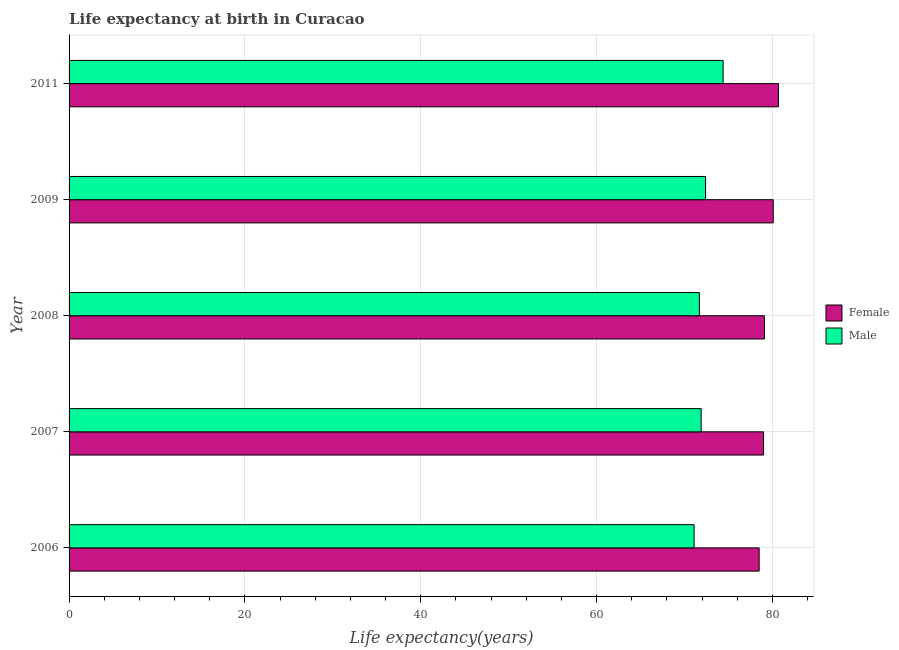How many different coloured bars are there?
Your answer should be very brief. 2. Are the number of bars per tick equal to the number of legend labels?
Your response must be concise. Yes. What is the label of the 4th group of bars from the top?
Your response must be concise. 2007. In how many cases, is the number of bars for a given year not equal to the number of legend labels?
Keep it short and to the point. 0. What is the life expectancy(female) in 2011?
Your response must be concise. 80.7. Across all years, what is the maximum life expectancy(male)?
Keep it short and to the point. 74.4. Across all years, what is the minimum life expectancy(female)?
Give a very brief answer. 78.5. In which year was the life expectancy(male) maximum?
Make the answer very short. 2011. What is the total life expectancy(male) in the graph?
Your answer should be compact. 361.5. What is the difference between the life expectancy(female) in 2008 and the life expectancy(male) in 2011?
Your answer should be compact. 4.7. What is the average life expectancy(female) per year?
Your answer should be very brief. 79.48. In the year 2009, what is the difference between the life expectancy(female) and life expectancy(male)?
Your answer should be very brief. 7.7. In how many years, is the life expectancy(male) greater than 76 years?
Give a very brief answer. 0. What is the ratio of the life expectancy(male) in 2008 to that in 2009?
Keep it short and to the point. 0.99. Is the life expectancy(female) in 2006 less than that in 2007?
Your answer should be compact. Yes. Is the sum of the life expectancy(female) in 2006 and 2009 greater than the maximum life expectancy(male) across all years?
Provide a succinct answer. Yes. Are all the bars in the graph horizontal?
Offer a terse response. Yes. What is the difference between two consecutive major ticks on the X-axis?
Keep it short and to the point. 20. Are the values on the major ticks of X-axis written in scientific E-notation?
Keep it short and to the point. No. Does the graph contain any zero values?
Your response must be concise. No. Where does the legend appear in the graph?
Your response must be concise. Center right. What is the title of the graph?
Ensure brevity in your answer.  Life expectancy at birth in Curacao. Does "Official aid received" appear as one of the legend labels in the graph?
Provide a short and direct response. No. What is the label or title of the X-axis?
Your answer should be compact. Life expectancy(years). What is the label or title of the Y-axis?
Keep it short and to the point. Year. What is the Life expectancy(years) in Female in 2006?
Offer a very short reply. 78.5. What is the Life expectancy(years) in Male in 2006?
Offer a very short reply. 71.1. What is the Life expectancy(years) in Female in 2007?
Keep it short and to the point. 79. What is the Life expectancy(years) in Male in 2007?
Offer a very short reply. 71.9. What is the Life expectancy(years) in Female in 2008?
Offer a terse response. 79.1. What is the Life expectancy(years) in Male in 2008?
Offer a terse response. 71.7. What is the Life expectancy(years) in Female in 2009?
Offer a very short reply. 80.1. What is the Life expectancy(years) of Male in 2009?
Your response must be concise. 72.4. What is the Life expectancy(years) of Female in 2011?
Provide a succinct answer. 80.7. What is the Life expectancy(years) of Male in 2011?
Give a very brief answer. 74.4. Across all years, what is the maximum Life expectancy(years) in Female?
Your answer should be very brief. 80.7. Across all years, what is the maximum Life expectancy(years) of Male?
Your response must be concise. 74.4. Across all years, what is the minimum Life expectancy(years) in Female?
Provide a short and direct response. 78.5. Across all years, what is the minimum Life expectancy(years) in Male?
Offer a very short reply. 71.1. What is the total Life expectancy(years) in Female in the graph?
Offer a very short reply. 397.4. What is the total Life expectancy(years) in Male in the graph?
Provide a short and direct response. 361.5. What is the difference between the Life expectancy(years) of Female in 2006 and that in 2007?
Provide a succinct answer. -0.5. What is the difference between the Life expectancy(years) in Male in 2006 and that in 2007?
Provide a short and direct response. -0.8. What is the difference between the Life expectancy(years) of Female in 2006 and that in 2008?
Keep it short and to the point. -0.6. What is the difference between the Life expectancy(years) in Male in 2006 and that in 2011?
Provide a succinct answer. -3.3. What is the difference between the Life expectancy(years) in Female in 2007 and that in 2008?
Make the answer very short. -0.1. What is the difference between the Life expectancy(years) in Male in 2007 and that in 2008?
Give a very brief answer. 0.2. What is the difference between the Life expectancy(years) of Female in 2008 and that in 2009?
Provide a short and direct response. -1. What is the difference between the Life expectancy(years) of Female in 2008 and that in 2011?
Provide a short and direct response. -1.6. What is the difference between the Life expectancy(years) of Male in 2008 and that in 2011?
Offer a terse response. -2.7. What is the difference between the Life expectancy(years) in Male in 2009 and that in 2011?
Provide a succinct answer. -2. What is the difference between the Life expectancy(years) of Female in 2006 and the Life expectancy(years) of Male in 2009?
Give a very brief answer. 6.1. What is the difference between the Life expectancy(years) in Female in 2006 and the Life expectancy(years) in Male in 2011?
Ensure brevity in your answer.  4.1. What is the difference between the Life expectancy(years) of Female in 2007 and the Life expectancy(years) of Male in 2008?
Offer a terse response. 7.3. What is the difference between the Life expectancy(years) of Female in 2007 and the Life expectancy(years) of Male in 2009?
Ensure brevity in your answer.  6.6. What is the difference between the Life expectancy(years) in Female in 2007 and the Life expectancy(years) in Male in 2011?
Make the answer very short. 4.6. What is the difference between the Life expectancy(years) of Female in 2008 and the Life expectancy(years) of Male in 2009?
Keep it short and to the point. 6.7. What is the average Life expectancy(years) of Female per year?
Offer a terse response. 79.48. What is the average Life expectancy(years) in Male per year?
Provide a succinct answer. 72.3. In the year 2007, what is the difference between the Life expectancy(years) of Female and Life expectancy(years) of Male?
Make the answer very short. 7.1. In the year 2008, what is the difference between the Life expectancy(years) of Female and Life expectancy(years) of Male?
Offer a very short reply. 7.4. In the year 2009, what is the difference between the Life expectancy(years) of Female and Life expectancy(years) of Male?
Offer a very short reply. 7.7. In the year 2011, what is the difference between the Life expectancy(years) of Female and Life expectancy(years) of Male?
Make the answer very short. 6.3. What is the ratio of the Life expectancy(years) in Female in 2006 to that in 2007?
Offer a very short reply. 0.99. What is the ratio of the Life expectancy(years) of Male in 2006 to that in 2007?
Give a very brief answer. 0.99. What is the ratio of the Life expectancy(years) in Female in 2006 to that in 2008?
Your answer should be very brief. 0.99. What is the ratio of the Life expectancy(years) of Female in 2006 to that in 2009?
Your response must be concise. 0.98. What is the ratio of the Life expectancy(years) in Female in 2006 to that in 2011?
Make the answer very short. 0.97. What is the ratio of the Life expectancy(years) of Male in 2006 to that in 2011?
Provide a succinct answer. 0.96. What is the ratio of the Life expectancy(years) of Female in 2007 to that in 2008?
Give a very brief answer. 1. What is the ratio of the Life expectancy(years) in Male in 2007 to that in 2008?
Provide a succinct answer. 1. What is the ratio of the Life expectancy(years) in Female in 2007 to that in 2009?
Your answer should be very brief. 0.99. What is the ratio of the Life expectancy(years) of Female in 2007 to that in 2011?
Make the answer very short. 0.98. What is the ratio of the Life expectancy(years) of Male in 2007 to that in 2011?
Ensure brevity in your answer.  0.97. What is the ratio of the Life expectancy(years) of Female in 2008 to that in 2009?
Make the answer very short. 0.99. What is the ratio of the Life expectancy(years) of Male in 2008 to that in 2009?
Your response must be concise. 0.99. What is the ratio of the Life expectancy(years) of Female in 2008 to that in 2011?
Your response must be concise. 0.98. What is the ratio of the Life expectancy(years) in Male in 2008 to that in 2011?
Your response must be concise. 0.96. What is the ratio of the Life expectancy(years) in Female in 2009 to that in 2011?
Keep it short and to the point. 0.99. What is the ratio of the Life expectancy(years) of Male in 2009 to that in 2011?
Provide a succinct answer. 0.97. What is the difference between the highest and the lowest Life expectancy(years) of Female?
Your answer should be very brief. 2.2. 